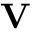<formula> <loc_0><loc_0><loc_500><loc_500>V</formula> 